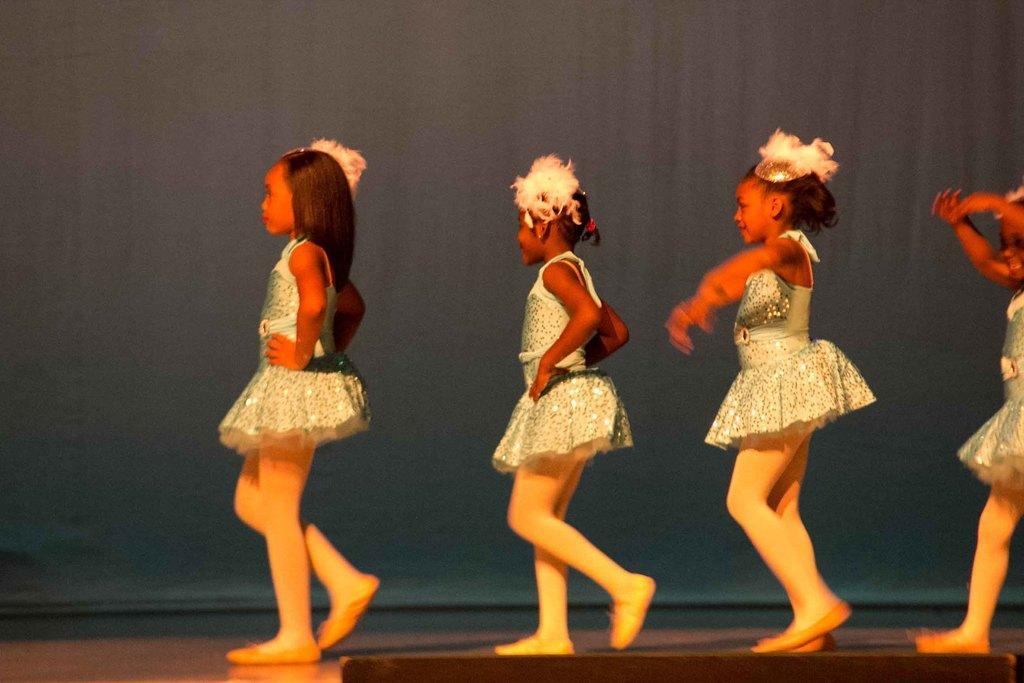In one or two sentences, can you explain what this image depicts? This image is taken indoors. At the bottom of the image there is a floor. In the background there is a cloth which is black in color. In the middle of the image four kids are walking on the floor. 